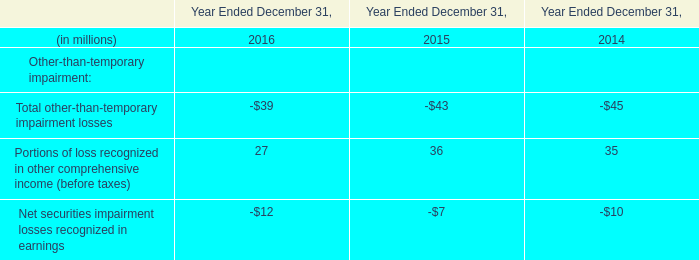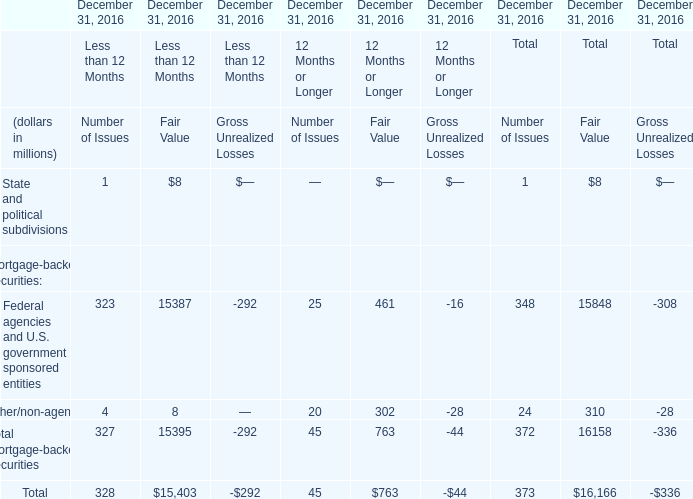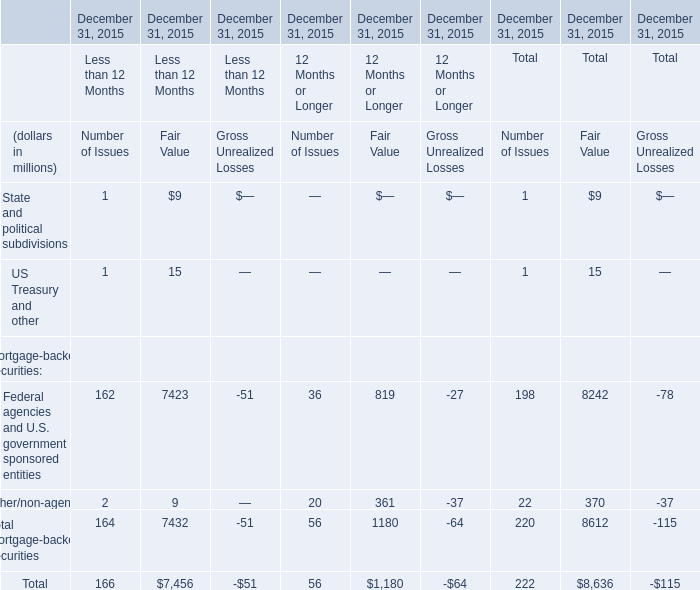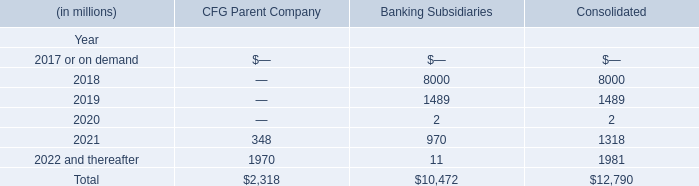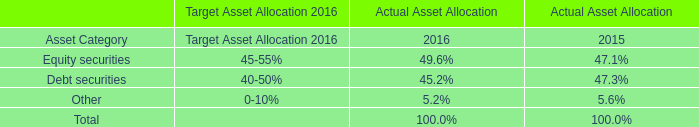In the year with largest amount of Portions of loss recognized in other comprehensive income (before taxes), what's the increasing rate of Net securities impairment losses recognized in earnings? 
Computations: ((-7 + 10) / -10)
Answer: -0.3. 